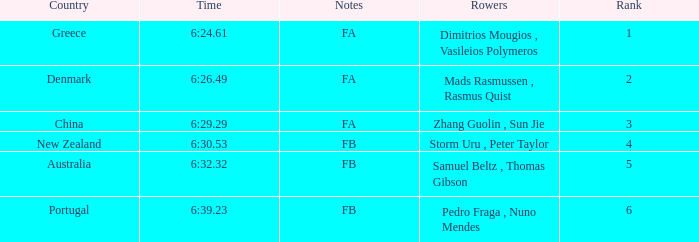Who are the rowers that achieved a time of 6:24.61? Dimitrios Mougios , Vasileios Polymeros. 